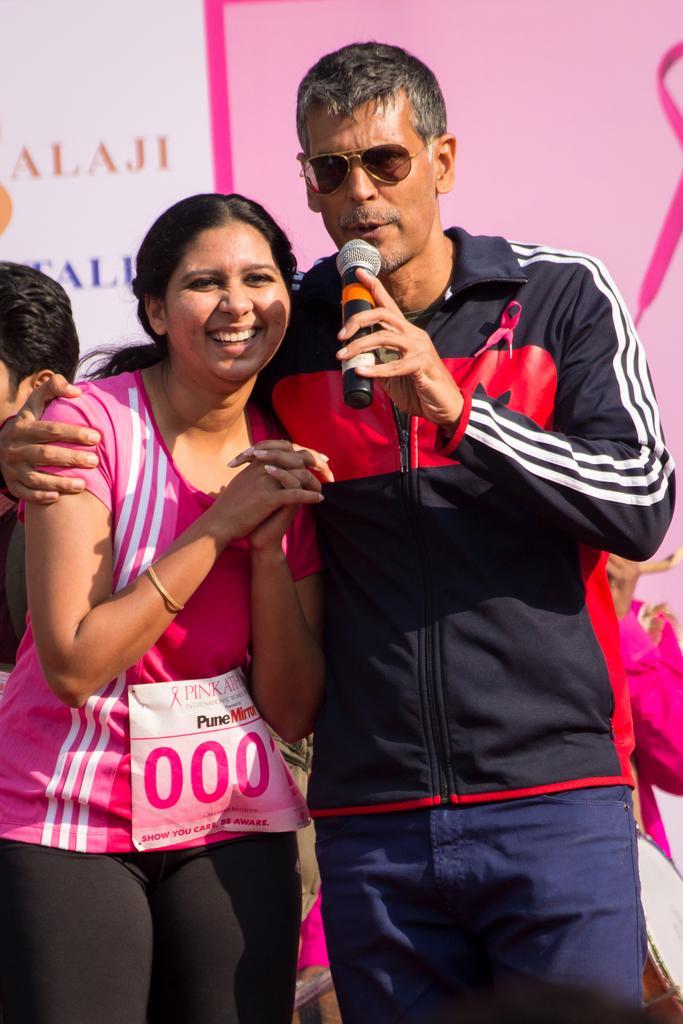Describe this image in one or two sentences. In this image there man holding a mic in his hand and wearing glasses, beside him there is a women standing, in the background there is a pink poster on that there is some text. 